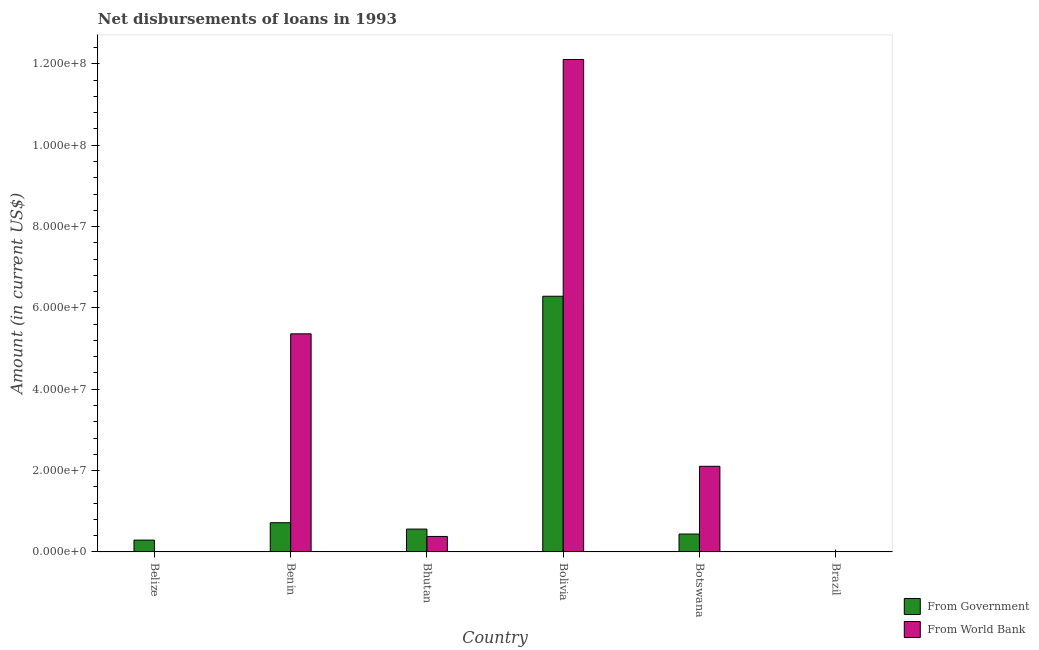Are the number of bars per tick equal to the number of legend labels?
Your answer should be very brief. No. How many bars are there on the 2nd tick from the right?
Ensure brevity in your answer.  2. What is the label of the 4th group of bars from the left?
Provide a succinct answer. Bolivia. What is the net disbursements of loan from government in Bolivia?
Keep it short and to the point. 6.29e+07. Across all countries, what is the maximum net disbursements of loan from government?
Make the answer very short. 6.29e+07. In which country was the net disbursements of loan from government maximum?
Your answer should be very brief. Bolivia. What is the total net disbursements of loan from government in the graph?
Provide a succinct answer. 8.30e+07. What is the difference between the net disbursements of loan from world bank in Benin and that in Bhutan?
Make the answer very short. 4.98e+07. What is the difference between the net disbursements of loan from world bank in Brazil and the net disbursements of loan from government in Botswana?
Ensure brevity in your answer.  -4.39e+06. What is the average net disbursements of loan from government per country?
Provide a short and direct response. 1.38e+07. What is the difference between the net disbursements of loan from world bank and net disbursements of loan from government in Benin?
Give a very brief answer. 4.64e+07. What is the ratio of the net disbursements of loan from world bank in Bhutan to that in Bolivia?
Your answer should be compact. 0.03. Is the difference between the net disbursements of loan from world bank in Benin and Bolivia greater than the difference between the net disbursements of loan from government in Benin and Bolivia?
Give a very brief answer. No. What is the difference between the highest and the second highest net disbursements of loan from government?
Offer a terse response. 5.57e+07. What is the difference between the highest and the lowest net disbursements of loan from world bank?
Ensure brevity in your answer.  1.21e+08. In how many countries, is the net disbursements of loan from government greater than the average net disbursements of loan from government taken over all countries?
Ensure brevity in your answer.  1. Is the sum of the net disbursements of loan from government in Benin and Bolivia greater than the maximum net disbursements of loan from world bank across all countries?
Your response must be concise. No. How many bars are there?
Give a very brief answer. 9. What is the difference between two consecutive major ticks on the Y-axis?
Your answer should be very brief. 2.00e+07. Are the values on the major ticks of Y-axis written in scientific E-notation?
Provide a short and direct response. Yes. Does the graph contain any zero values?
Offer a very short reply. Yes. Where does the legend appear in the graph?
Your response must be concise. Bottom right. How many legend labels are there?
Your answer should be very brief. 2. How are the legend labels stacked?
Provide a short and direct response. Vertical. What is the title of the graph?
Offer a very short reply. Net disbursements of loans in 1993. Does "Tetanus" appear as one of the legend labels in the graph?
Provide a short and direct response. No. What is the label or title of the X-axis?
Ensure brevity in your answer.  Country. What is the Amount (in current US$) in From Government in Belize?
Your answer should be very brief. 2.90e+06. What is the Amount (in current US$) of From World Bank in Belize?
Provide a succinct answer. 0. What is the Amount (in current US$) of From Government in Benin?
Your answer should be compact. 7.18e+06. What is the Amount (in current US$) of From World Bank in Benin?
Offer a terse response. 5.36e+07. What is the Amount (in current US$) of From Government in Bhutan?
Your answer should be very brief. 5.61e+06. What is the Amount (in current US$) in From World Bank in Bhutan?
Provide a short and direct response. 3.80e+06. What is the Amount (in current US$) in From Government in Bolivia?
Offer a very short reply. 6.29e+07. What is the Amount (in current US$) in From World Bank in Bolivia?
Make the answer very short. 1.21e+08. What is the Amount (in current US$) of From Government in Botswana?
Offer a terse response. 4.39e+06. What is the Amount (in current US$) of From World Bank in Botswana?
Ensure brevity in your answer.  2.10e+07. What is the Amount (in current US$) in From Government in Brazil?
Your answer should be very brief. 0. Across all countries, what is the maximum Amount (in current US$) of From Government?
Your answer should be very brief. 6.29e+07. Across all countries, what is the maximum Amount (in current US$) in From World Bank?
Provide a succinct answer. 1.21e+08. Across all countries, what is the minimum Amount (in current US$) in From Government?
Offer a very short reply. 0. Across all countries, what is the minimum Amount (in current US$) in From World Bank?
Your answer should be very brief. 0. What is the total Amount (in current US$) of From Government in the graph?
Give a very brief answer. 8.30e+07. What is the total Amount (in current US$) of From World Bank in the graph?
Ensure brevity in your answer.  2.00e+08. What is the difference between the Amount (in current US$) in From Government in Belize and that in Benin?
Ensure brevity in your answer.  -4.28e+06. What is the difference between the Amount (in current US$) of From Government in Belize and that in Bhutan?
Your answer should be compact. -2.70e+06. What is the difference between the Amount (in current US$) of From Government in Belize and that in Bolivia?
Ensure brevity in your answer.  -6.00e+07. What is the difference between the Amount (in current US$) of From Government in Belize and that in Botswana?
Offer a very short reply. -1.49e+06. What is the difference between the Amount (in current US$) in From Government in Benin and that in Bhutan?
Offer a terse response. 1.57e+06. What is the difference between the Amount (in current US$) in From World Bank in Benin and that in Bhutan?
Make the answer very short. 4.98e+07. What is the difference between the Amount (in current US$) in From Government in Benin and that in Bolivia?
Provide a short and direct response. -5.57e+07. What is the difference between the Amount (in current US$) in From World Bank in Benin and that in Bolivia?
Provide a succinct answer. -6.74e+07. What is the difference between the Amount (in current US$) in From Government in Benin and that in Botswana?
Ensure brevity in your answer.  2.79e+06. What is the difference between the Amount (in current US$) of From World Bank in Benin and that in Botswana?
Give a very brief answer. 3.26e+07. What is the difference between the Amount (in current US$) of From Government in Bhutan and that in Bolivia?
Ensure brevity in your answer.  -5.73e+07. What is the difference between the Amount (in current US$) in From World Bank in Bhutan and that in Bolivia?
Your response must be concise. -1.17e+08. What is the difference between the Amount (in current US$) in From Government in Bhutan and that in Botswana?
Your answer should be very brief. 1.22e+06. What is the difference between the Amount (in current US$) of From World Bank in Bhutan and that in Botswana?
Offer a terse response. -1.72e+07. What is the difference between the Amount (in current US$) in From Government in Bolivia and that in Botswana?
Your answer should be very brief. 5.85e+07. What is the difference between the Amount (in current US$) of From World Bank in Bolivia and that in Botswana?
Make the answer very short. 1.00e+08. What is the difference between the Amount (in current US$) of From Government in Belize and the Amount (in current US$) of From World Bank in Benin?
Your answer should be compact. -5.07e+07. What is the difference between the Amount (in current US$) in From Government in Belize and the Amount (in current US$) in From World Bank in Bhutan?
Offer a very short reply. -8.97e+05. What is the difference between the Amount (in current US$) in From Government in Belize and the Amount (in current US$) in From World Bank in Bolivia?
Your answer should be compact. -1.18e+08. What is the difference between the Amount (in current US$) of From Government in Belize and the Amount (in current US$) of From World Bank in Botswana?
Ensure brevity in your answer.  -1.81e+07. What is the difference between the Amount (in current US$) in From Government in Benin and the Amount (in current US$) in From World Bank in Bhutan?
Keep it short and to the point. 3.38e+06. What is the difference between the Amount (in current US$) in From Government in Benin and the Amount (in current US$) in From World Bank in Bolivia?
Your response must be concise. -1.14e+08. What is the difference between the Amount (in current US$) of From Government in Benin and the Amount (in current US$) of From World Bank in Botswana?
Provide a succinct answer. -1.39e+07. What is the difference between the Amount (in current US$) of From Government in Bhutan and the Amount (in current US$) of From World Bank in Bolivia?
Keep it short and to the point. -1.15e+08. What is the difference between the Amount (in current US$) of From Government in Bhutan and the Amount (in current US$) of From World Bank in Botswana?
Keep it short and to the point. -1.54e+07. What is the difference between the Amount (in current US$) of From Government in Bolivia and the Amount (in current US$) of From World Bank in Botswana?
Your response must be concise. 4.18e+07. What is the average Amount (in current US$) in From Government per country?
Make the answer very short. 1.38e+07. What is the average Amount (in current US$) in From World Bank per country?
Your answer should be compact. 3.33e+07. What is the difference between the Amount (in current US$) of From Government and Amount (in current US$) of From World Bank in Benin?
Provide a short and direct response. -4.64e+07. What is the difference between the Amount (in current US$) in From Government and Amount (in current US$) in From World Bank in Bhutan?
Give a very brief answer. 1.81e+06. What is the difference between the Amount (in current US$) of From Government and Amount (in current US$) of From World Bank in Bolivia?
Give a very brief answer. -5.82e+07. What is the difference between the Amount (in current US$) of From Government and Amount (in current US$) of From World Bank in Botswana?
Make the answer very short. -1.67e+07. What is the ratio of the Amount (in current US$) in From Government in Belize to that in Benin?
Your answer should be very brief. 0.4. What is the ratio of the Amount (in current US$) in From Government in Belize to that in Bhutan?
Offer a very short reply. 0.52. What is the ratio of the Amount (in current US$) in From Government in Belize to that in Bolivia?
Provide a succinct answer. 0.05. What is the ratio of the Amount (in current US$) in From Government in Belize to that in Botswana?
Give a very brief answer. 0.66. What is the ratio of the Amount (in current US$) in From Government in Benin to that in Bhutan?
Your response must be concise. 1.28. What is the ratio of the Amount (in current US$) of From World Bank in Benin to that in Bhutan?
Ensure brevity in your answer.  14.1. What is the ratio of the Amount (in current US$) in From Government in Benin to that in Bolivia?
Offer a very short reply. 0.11. What is the ratio of the Amount (in current US$) in From World Bank in Benin to that in Bolivia?
Keep it short and to the point. 0.44. What is the ratio of the Amount (in current US$) in From Government in Benin to that in Botswana?
Provide a short and direct response. 1.63. What is the ratio of the Amount (in current US$) of From World Bank in Benin to that in Botswana?
Ensure brevity in your answer.  2.55. What is the ratio of the Amount (in current US$) in From Government in Bhutan to that in Bolivia?
Your answer should be compact. 0.09. What is the ratio of the Amount (in current US$) in From World Bank in Bhutan to that in Bolivia?
Your answer should be very brief. 0.03. What is the ratio of the Amount (in current US$) of From Government in Bhutan to that in Botswana?
Your answer should be compact. 1.28. What is the ratio of the Amount (in current US$) of From World Bank in Bhutan to that in Botswana?
Provide a short and direct response. 0.18. What is the ratio of the Amount (in current US$) of From Government in Bolivia to that in Botswana?
Offer a very short reply. 14.31. What is the ratio of the Amount (in current US$) of From World Bank in Bolivia to that in Botswana?
Your response must be concise. 5.75. What is the difference between the highest and the second highest Amount (in current US$) in From Government?
Give a very brief answer. 5.57e+07. What is the difference between the highest and the second highest Amount (in current US$) in From World Bank?
Offer a terse response. 6.74e+07. What is the difference between the highest and the lowest Amount (in current US$) of From Government?
Keep it short and to the point. 6.29e+07. What is the difference between the highest and the lowest Amount (in current US$) in From World Bank?
Keep it short and to the point. 1.21e+08. 